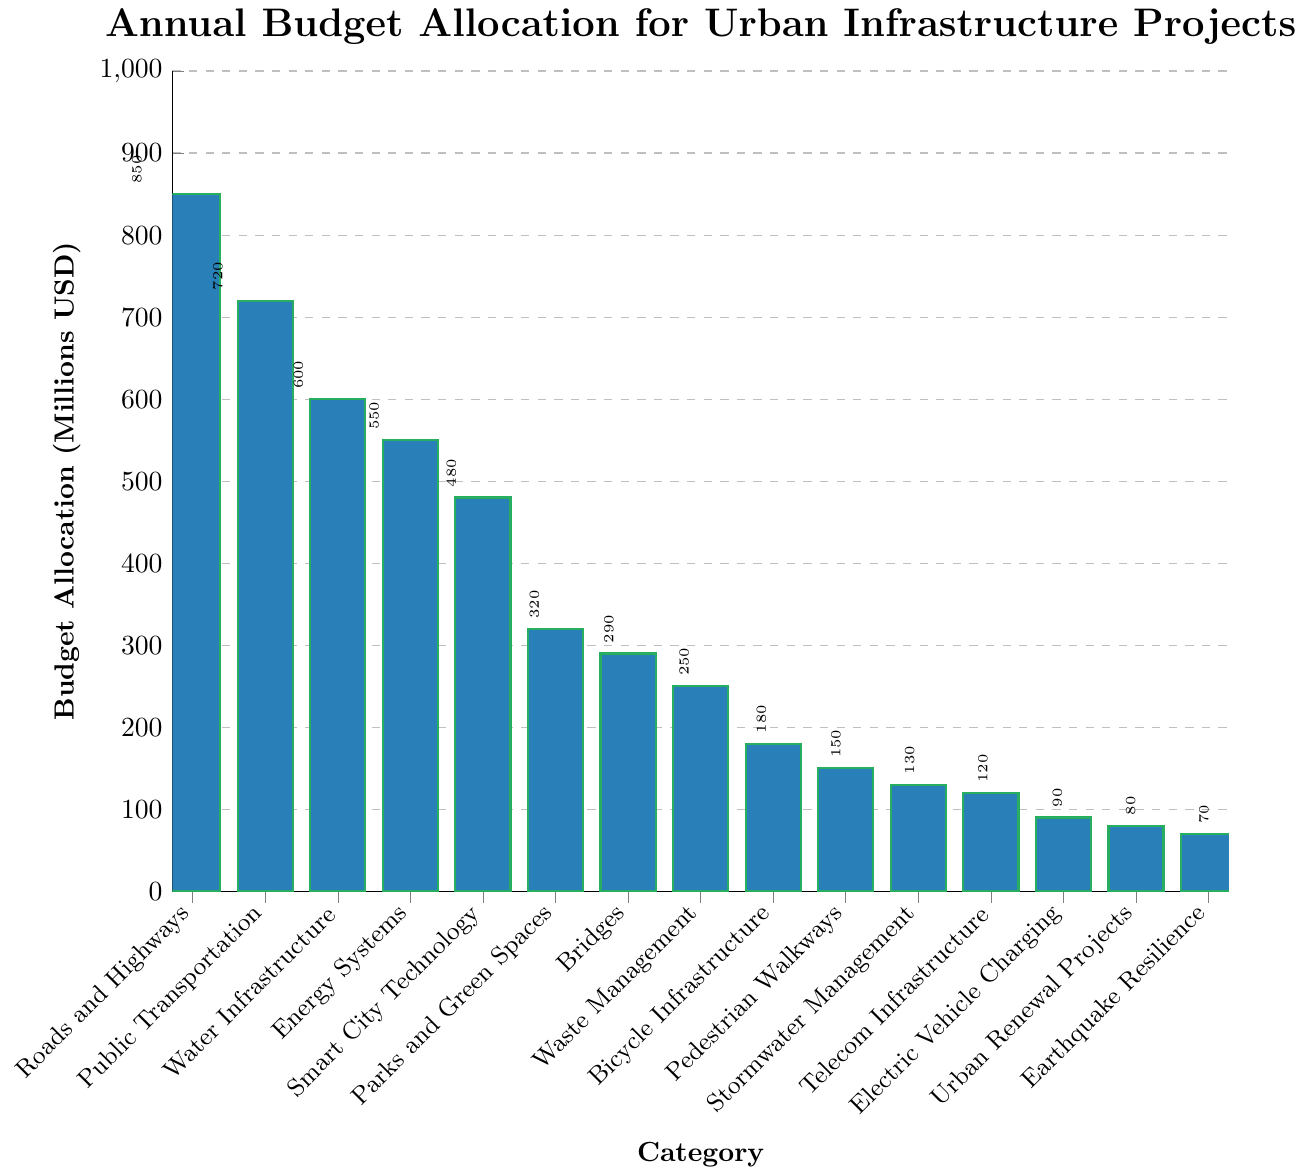Which category has the highest budget allocation? By observing the heights of the bars, the tallest bar corresponds to "Roads and Highways" with a budget allocation of 850 million USD.
Answer: Roads and Highways What is the combined budget allocation for Bicycle Infrastructure and Pedestrian Walkways? The budget allocation for Bicycle Infrastructure is 180 million USD, and for Pedestrian Walkways, it is 150 million USD. Summing them up: 180 + 150 = 330 million USD.
Answer: 330 million USD How much more funding is allocated to Water Infrastructure than Smart City Technology? Water Infrastructure has a budget allocation of 600 million USD, while Smart City Technology has 480 million USD. The difference is 600 - 480 = 120 million USD.
Answer: 120 million USD Which category has the smallest budget allocation? By observing the heights of the bars, the shortest bar corresponds to "Earthquake Resilience" with a budget allocation of 70 million USD.
Answer: Earthquake Resilience Is the budget for Public Transportation greater than that for Energy Systems? The budget allocation for Public Transportation is 720 million USD, and for Energy Systems, it is 550 million USD. Since 720 > 550, the budget for Public Transportation is indeed greater.
Answer: Yes What is the average budget allocation for the three highest-funded categories? The three highest-funded categories are Roads and Highways (850 million USD), Public Transportation (720 million USD), and Water Infrastructure (600 million USD). The average is calculated as (850 + 720 + 600) / 3 = 2170 / 3 = 723.33 million USD.
Answer: 723.33 million USD Which has a higher budget, Telecom Infrastructure or Stormwater Management? Telecom Infrastructure has a budget allocation of 120 million USD, while Stormwater Management has 130 million USD. Since 130 > 120, Stormwater Management has a higher budget.
Answer: Stormwater Management By how much does the budget for Roads and Highways exceed the combined budget for Electric Vehicle Charging and Urban Renewal Projects? The budget for Roads and Highways is 850 million USD. The combined budget for Electric Vehicle Charging (90 million USD) and Urban Renewal Projects (80 million USD) is 90 + 80 = 170 million USD. The difference is 850 - 170 = 680 million USD.
Answer: 680 million USD If the total budget allocation is 5000 million USD, what proportion is allocated to Bridges? The budget allocation for Bridges is 290 million USD. To find the proportion: (290 / 5000) * 100 = 5.8%.
Answer: 5.8% Compare the budgets for Parks and Green Spaces and Waste Management and identify which one is larger. Parks and Green Spaces have a budget allocation of 320 million USD, while Waste Management has 250 million USD. Since 320 > 250, the budget for Parks and Green Spaces is larger.
Answer: Parks and Green Spaces 